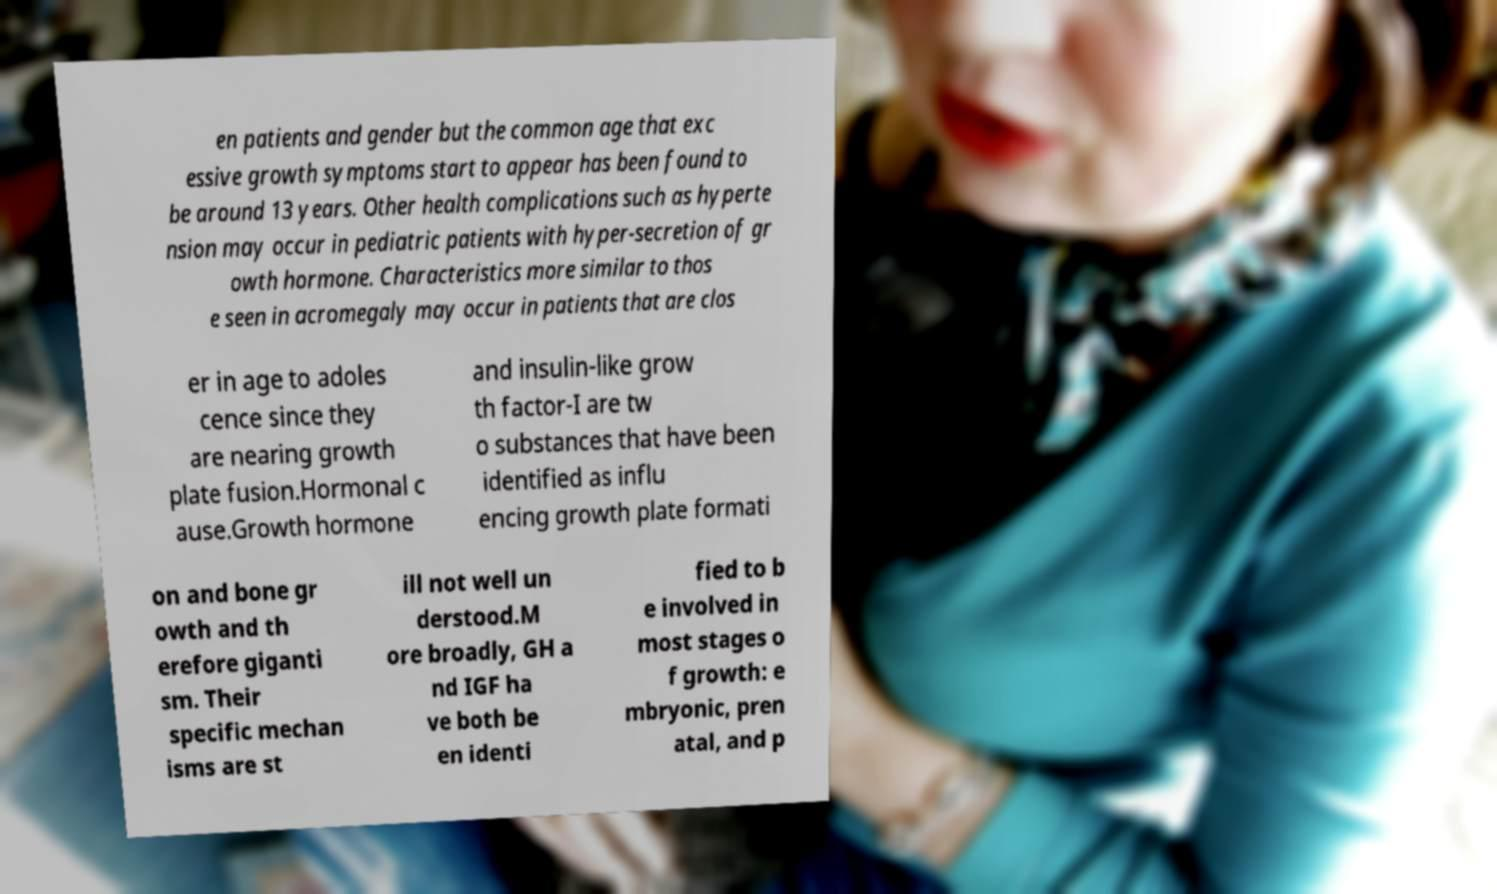I need the written content from this picture converted into text. Can you do that? en patients and gender but the common age that exc essive growth symptoms start to appear has been found to be around 13 years. Other health complications such as hyperte nsion may occur in pediatric patients with hyper-secretion of gr owth hormone. Characteristics more similar to thos e seen in acromegaly may occur in patients that are clos er in age to adoles cence since they are nearing growth plate fusion.Hormonal c ause.Growth hormone and insulin-like grow th factor-I are tw o substances that have been identified as influ encing growth plate formati on and bone gr owth and th erefore giganti sm. Their specific mechan isms are st ill not well un derstood.M ore broadly, GH a nd IGF ha ve both be en identi fied to b e involved in most stages o f growth: e mbryonic, pren atal, and p 